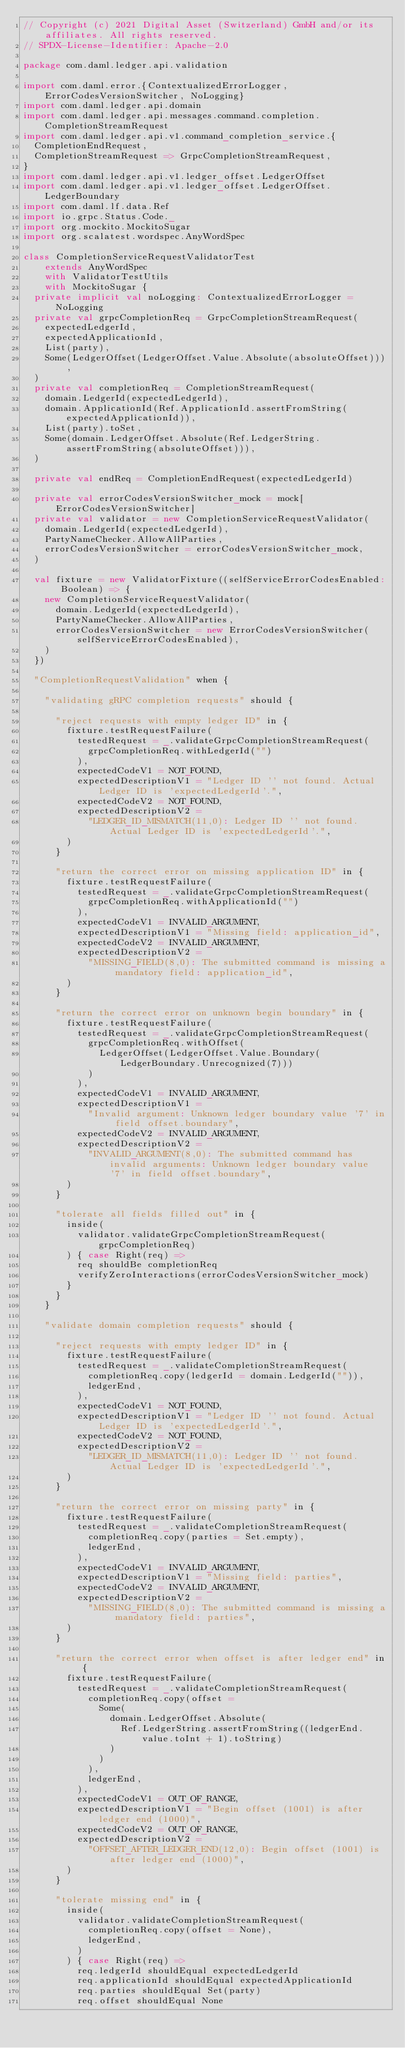Convert code to text. <code><loc_0><loc_0><loc_500><loc_500><_Scala_>// Copyright (c) 2021 Digital Asset (Switzerland) GmbH and/or its affiliates. All rights reserved.
// SPDX-License-Identifier: Apache-2.0

package com.daml.ledger.api.validation

import com.daml.error.{ContextualizedErrorLogger, ErrorCodesVersionSwitcher, NoLogging}
import com.daml.ledger.api.domain
import com.daml.ledger.api.messages.command.completion.CompletionStreamRequest
import com.daml.ledger.api.v1.command_completion_service.{
  CompletionEndRequest,
  CompletionStreamRequest => GrpcCompletionStreamRequest,
}
import com.daml.ledger.api.v1.ledger_offset.LedgerOffset
import com.daml.ledger.api.v1.ledger_offset.LedgerOffset.LedgerBoundary
import com.daml.lf.data.Ref
import io.grpc.Status.Code._
import org.mockito.MockitoSugar
import org.scalatest.wordspec.AnyWordSpec

class CompletionServiceRequestValidatorTest
    extends AnyWordSpec
    with ValidatorTestUtils
    with MockitoSugar {
  private implicit val noLogging: ContextualizedErrorLogger = NoLogging
  private val grpcCompletionReq = GrpcCompletionStreamRequest(
    expectedLedgerId,
    expectedApplicationId,
    List(party),
    Some(LedgerOffset(LedgerOffset.Value.Absolute(absoluteOffset))),
  )
  private val completionReq = CompletionStreamRequest(
    domain.LedgerId(expectedLedgerId),
    domain.ApplicationId(Ref.ApplicationId.assertFromString(expectedApplicationId)),
    List(party).toSet,
    Some(domain.LedgerOffset.Absolute(Ref.LedgerString.assertFromString(absoluteOffset))),
  )

  private val endReq = CompletionEndRequest(expectedLedgerId)

  private val errorCodesVersionSwitcher_mock = mock[ErrorCodesVersionSwitcher]
  private val validator = new CompletionServiceRequestValidator(
    domain.LedgerId(expectedLedgerId),
    PartyNameChecker.AllowAllParties,
    errorCodesVersionSwitcher = errorCodesVersionSwitcher_mock,
  )

  val fixture = new ValidatorFixture((selfServiceErrorCodesEnabled: Boolean) => {
    new CompletionServiceRequestValidator(
      domain.LedgerId(expectedLedgerId),
      PartyNameChecker.AllowAllParties,
      errorCodesVersionSwitcher = new ErrorCodesVersionSwitcher(selfServiceErrorCodesEnabled),
    )
  })

  "CompletionRequestValidation" when {

    "validating gRPC completion requests" should {

      "reject requests with empty ledger ID" in {
        fixture.testRequestFailure(
          testedRequest = _.validateGrpcCompletionStreamRequest(
            grpcCompletionReq.withLedgerId("")
          ),
          expectedCodeV1 = NOT_FOUND,
          expectedDescriptionV1 = "Ledger ID '' not found. Actual Ledger ID is 'expectedLedgerId'.",
          expectedCodeV2 = NOT_FOUND,
          expectedDescriptionV2 =
            "LEDGER_ID_MISMATCH(11,0): Ledger ID '' not found. Actual Ledger ID is 'expectedLedgerId'.",
        )
      }

      "return the correct error on missing application ID" in {
        fixture.testRequestFailure(
          testedRequest = _.validateGrpcCompletionStreamRequest(
            grpcCompletionReq.withApplicationId("")
          ),
          expectedCodeV1 = INVALID_ARGUMENT,
          expectedDescriptionV1 = "Missing field: application_id",
          expectedCodeV2 = INVALID_ARGUMENT,
          expectedDescriptionV2 =
            "MISSING_FIELD(8,0): The submitted command is missing a mandatory field: application_id",
        )
      }

      "return the correct error on unknown begin boundary" in {
        fixture.testRequestFailure(
          testedRequest = _.validateGrpcCompletionStreamRequest(
            grpcCompletionReq.withOffset(
              LedgerOffset(LedgerOffset.Value.Boundary(LedgerBoundary.Unrecognized(7)))
            )
          ),
          expectedCodeV1 = INVALID_ARGUMENT,
          expectedDescriptionV1 =
            "Invalid argument: Unknown ledger boundary value '7' in field offset.boundary",
          expectedCodeV2 = INVALID_ARGUMENT,
          expectedDescriptionV2 =
            "INVALID_ARGUMENT(8,0): The submitted command has invalid arguments: Unknown ledger boundary value '7' in field offset.boundary",
        )
      }

      "tolerate all fields filled out" in {
        inside(
          validator.validateGrpcCompletionStreamRequest(grpcCompletionReq)
        ) { case Right(req) =>
          req shouldBe completionReq
          verifyZeroInteractions(errorCodesVersionSwitcher_mock)
        }
      }
    }

    "validate domain completion requests" should {

      "reject requests with empty ledger ID" in {
        fixture.testRequestFailure(
          testedRequest = _.validateCompletionStreamRequest(
            completionReq.copy(ledgerId = domain.LedgerId("")),
            ledgerEnd,
          ),
          expectedCodeV1 = NOT_FOUND,
          expectedDescriptionV1 = "Ledger ID '' not found. Actual Ledger ID is 'expectedLedgerId'.",
          expectedCodeV2 = NOT_FOUND,
          expectedDescriptionV2 =
            "LEDGER_ID_MISMATCH(11,0): Ledger ID '' not found. Actual Ledger ID is 'expectedLedgerId'.",
        )
      }

      "return the correct error on missing party" in {
        fixture.testRequestFailure(
          testedRequest = _.validateCompletionStreamRequest(
            completionReq.copy(parties = Set.empty),
            ledgerEnd,
          ),
          expectedCodeV1 = INVALID_ARGUMENT,
          expectedDescriptionV1 = "Missing field: parties",
          expectedCodeV2 = INVALID_ARGUMENT,
          expectedDescriptionV2 =
            "MISSING_FIELD(8,0): The submitted command is missing a mandatory field: parties",
        )
      }

      "return the correct error when offset is after ledger end" in {
        fixture.testRequestFailure(
          testedRequest = _.validateCompletionStreamRequest(
            completionReq.copy(offset =
              Some(
                domain.LedgerOffset.Absolute(
                  Ref.LedgerString.assertFromString((ledgerEnd.value.toInt + 1).toString)
                )
              )
            ),
            ledgerEnd,
          ),
          expectedCodeV1 = OUT_OF_RANGE,
          expectedDescriptionV1 = "Begin offset (1001) is after ledger end (1000)",
          expectedCodeV2 = OUT_OF_RANGE,
          expectedDescriptionV2 =
            "OFFSET_AFTER_LEDGER_END(12,0): Begin offset (1001) is after ledger end (1000)",
        )
      }

      "tolerate missing end" in {
        inside(
          validator.validateCompletionStreamRequest(
            completionReq.copy(offset = None),
            ledgerEnd,
          )
        ) { case Right(req) =>
          req.ledgerId shouldEqual expectedLedgerId
          req.applicationId shouldEqual expectedApplicationId
          req.parties shouldEqual Set(party)
          req.offset shouldEqual None</code> 